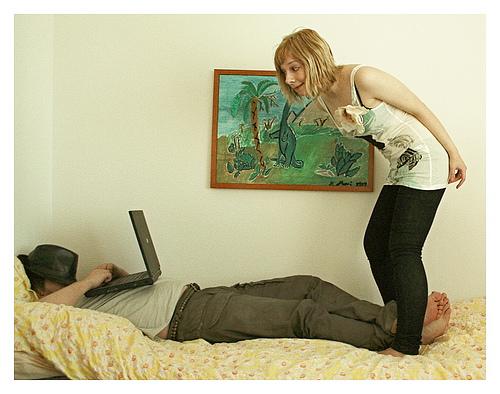Does the photographer have a sense of humor?
Write a very short answer. Yes. With what is the man's face covered?
Write a very short answer. Hat. Does the woman look sad?
Give a very brief answer. No. How many people are shown?
Write a very short answer. 2. 